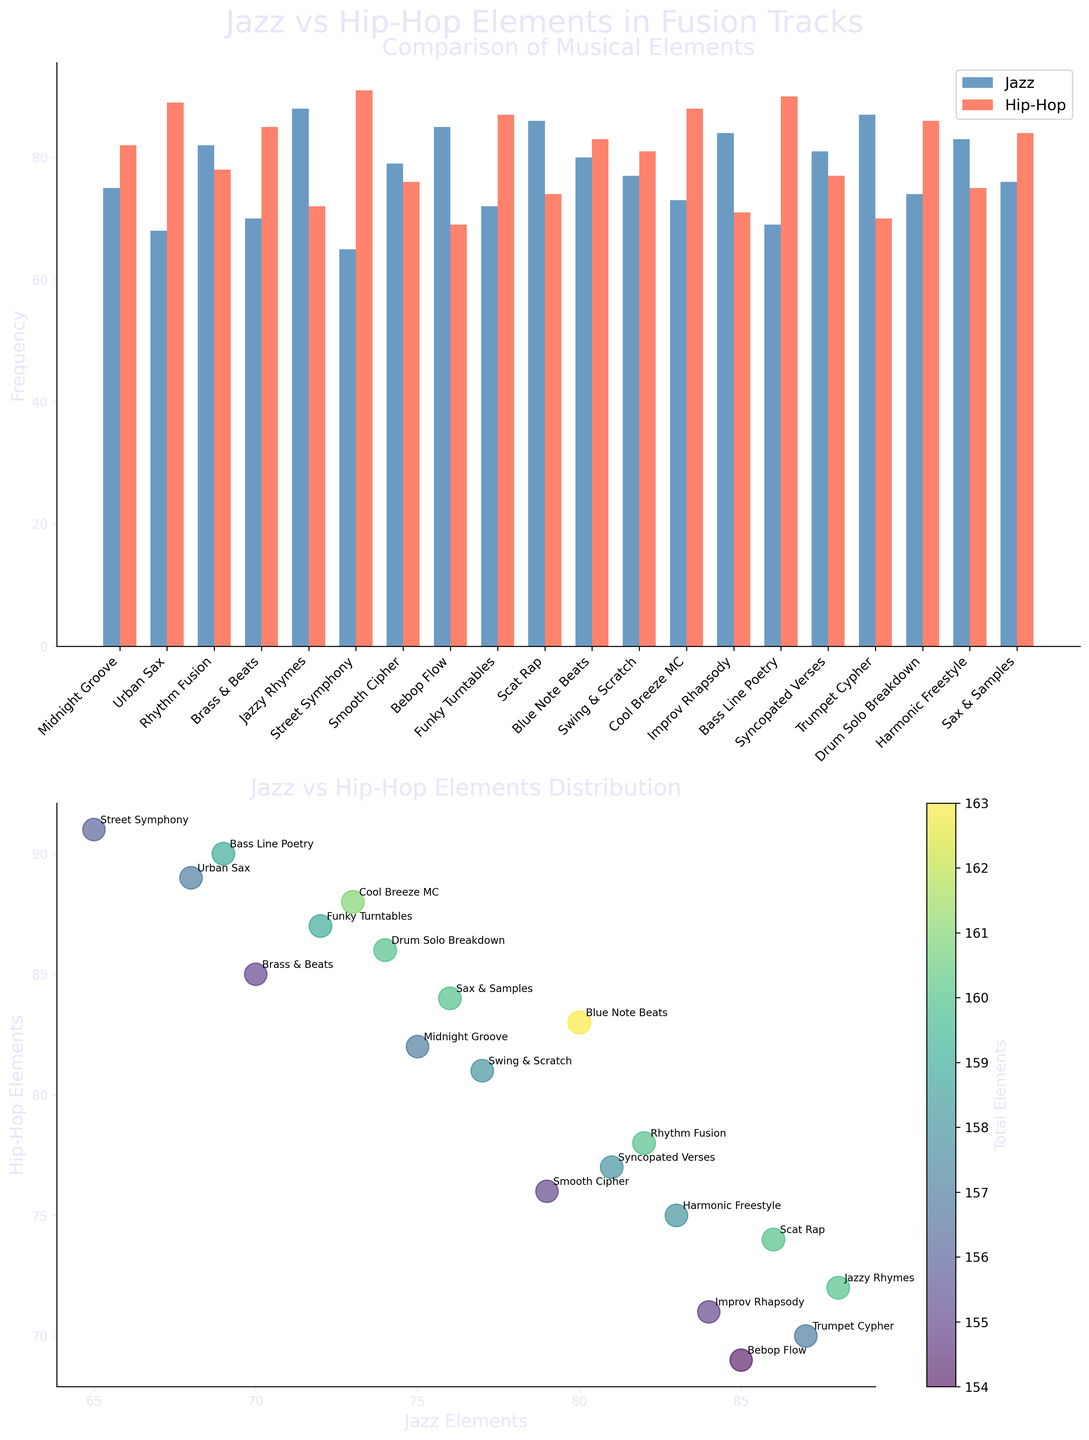What is the track with the highest frequency of Hip-Hop elements? From the bar plot, locate the tallest red bar representing Hip-Hop elements and check its corresponding track label. The tallest red bar corresponds to the track "Street Symphony."
Answer: "Street Symphony" Which track has the largest difference between Jazz and Hip-Hop elements? Calculate the differences between the Jazz and Hip-Hop elements for each track from the numerical values, then find the largest difference. "Street Symphony" and "Bass Line Poetry" both have differences of 26.
Answer: "Street Symphony" and "Bass Line Poetry" What is the average frequency of Jazz elements in all the tracks? Sum the frequencies of Jazz elements for all tracks, then divide by the number of tracks. (75+68+82+70+88+65+79+85+72+86+80+77+73+84+69+81+87+74+83+76) / 20 = 76.4
Answer: 76.4 Which track has almost equal frequencies of Jazz and Hip-Hop elements? In the bar plot, identify the bars where the height of the blue (Jazz) and red (Hip-Hop) bars are closest. "Smooth Cipher" has Jazz (79) and Hip-Hop (76), a difference of 3, the smallest difference.
Answer: "Smooth Cipher" What is the combined total frequency of Jazz and Hip-Hop elements in "Urban Sax"? Add the Jazz (68) and Hip-Hop (89) elements of the track "Urban Sax." 68 + 89 = 157
Answer: 157 Which element (Jazz or Hip-Hop) is more frequent in "Swing & Scratch"? Refer to the bar plot for "Swing & Scratch" and compare the heights of the Jazz and Hip-Hop bars. Jazz has 77, while Hip-Hop has 81, so Hip-Hop is more frequent.
Answer: Hip-Hop How many tracks have more than 80 frequencies of Hip-Hop elements? Count the number of tracks where the height of the red bars (Hip-Hop) in the bar plot is greater than 80. These tracks are "Midnight Groove," "Urban Sax," "Brass & Beats," "Street Symphony," "Funky Turntables," "Cool Breeze MC," "Bass Line Poetry," and "Sax & Samples." Total = 8
Answer: 8 Which track appears at the top right of the scatter plot (highest Jazz and Hip-Hop elements)? In the scatter plot, look for the point positioned highest and furthest to the right. This corresponds to the track "Scat Rap" with Jazz (86) and Hip-Hop (74).
Answer: "Scat Rap" What is the combined average frequency of Jazz and Hip-Hop elements for all tracks? Sum all Jazz and Hip-Hop elements, then divide by the number of tracks. Total Jazz: 1528, Total Hip-Hop: 1573. Combined Total: 3101. Average: 3101 / 20 = 155.05
Answer: 155.05 Which track has the lowest frequency of Jazz elements but a high frequency of Hip-Hop elements? Identify the track with the lowest Jazz elements and check its corresponding Hip-Hop elements. "Street Symphony" has the lowest Jazz (65) but a high Hip-Hop frequency (91).
Answer: "Street Symphony" 